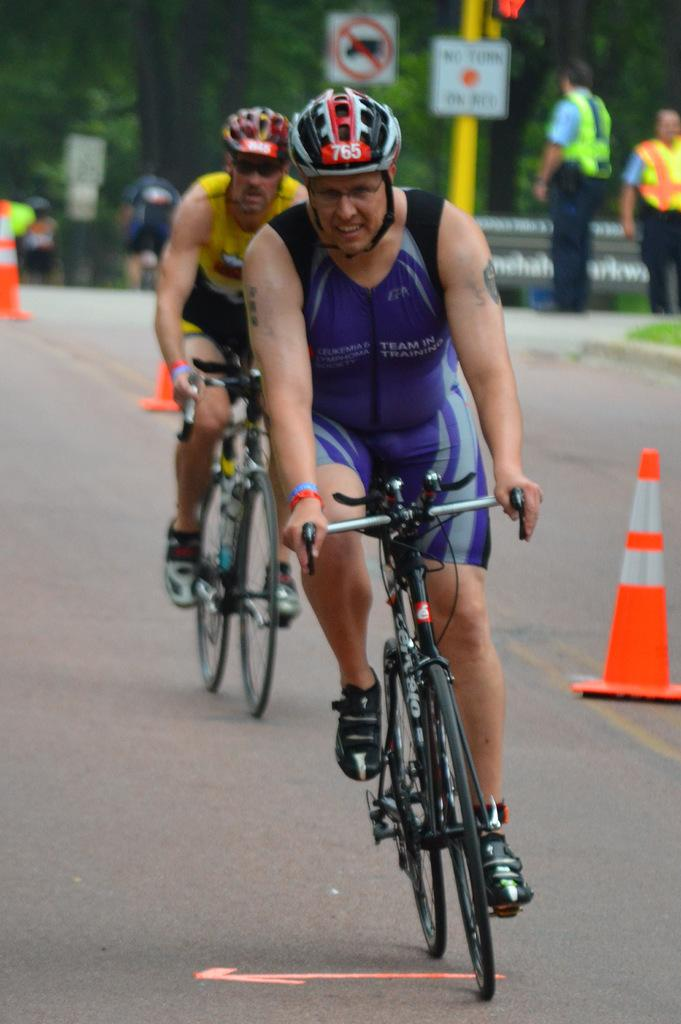What type of vegetation can be seen in the image? There are trees in the image. How many people are present in the image? There are two people in the image. What are the two people doing in the image? The two people are riding bicycles. How many cows can be seen grazing in the image? There are no cows present in the image; it features trees and two people riding bicycles. 